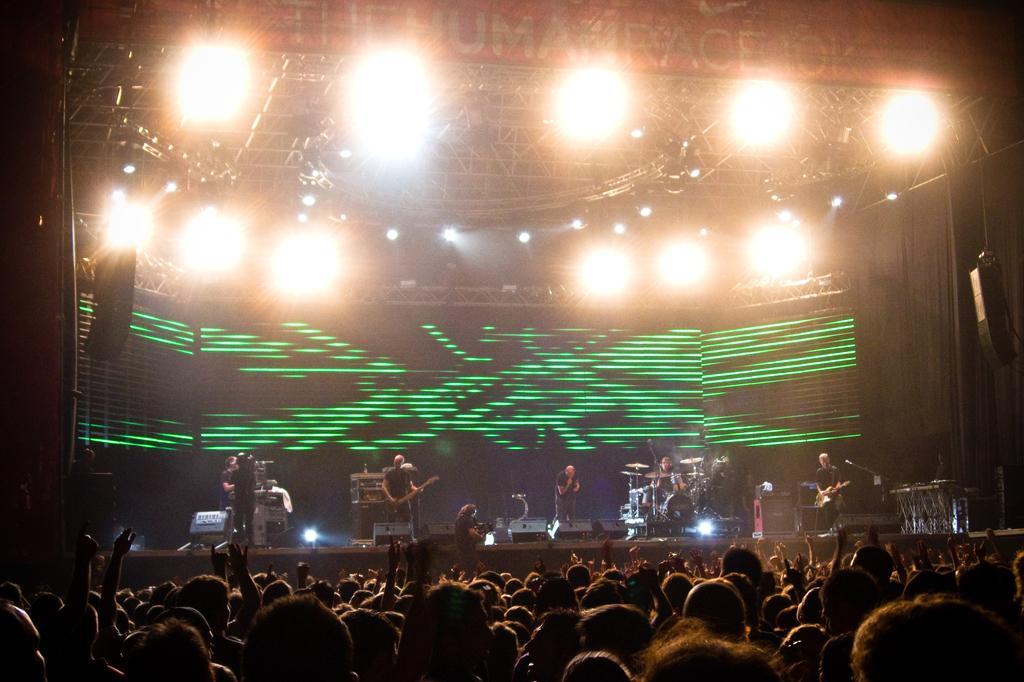Could you give a brief overview of what you see in this image? In this image at the bottom there are some people, and in the center there are some persons who are standing and some of them are holding guitars and some of them are playing drums. And also there are some mike's, musical instruments. On the top of the image there are some lights, and in the center there is a screen. 